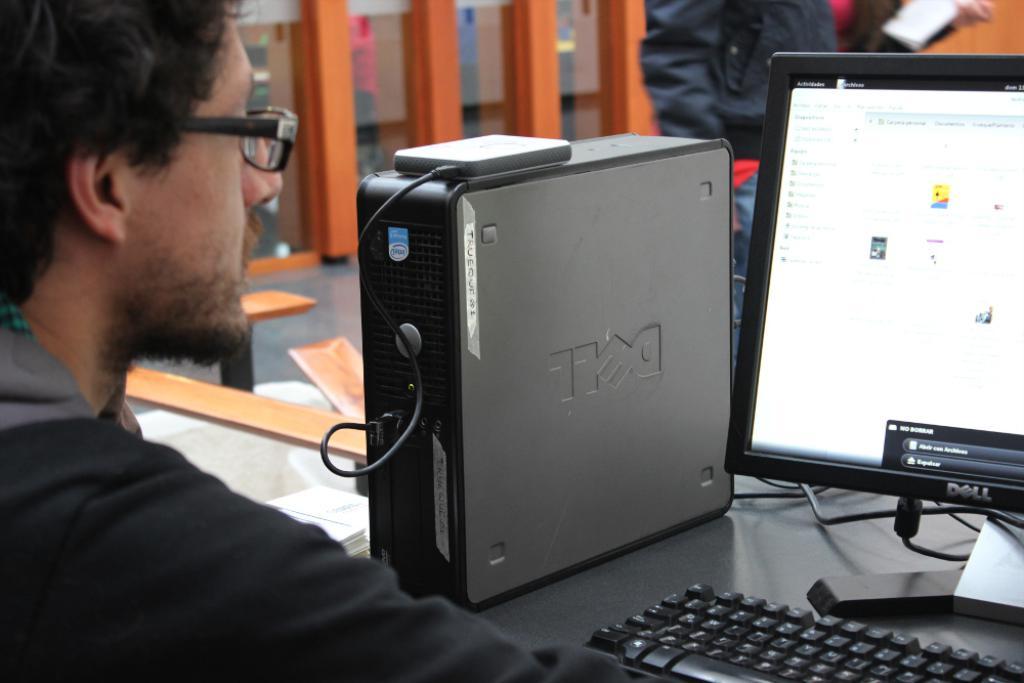What brand of computer is shown?
Your answer should be compact. Dell. A man using that laptop?
Provide a short and direct response. Answering does not require reading text in the image. 